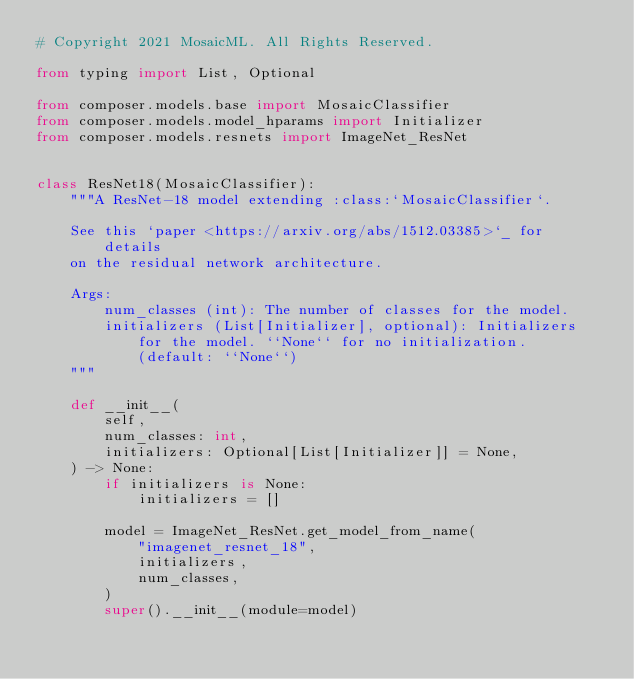<code> <loc_0><loc_0><loc_500><loc_500><_Python_># Copyright 2021 MosaicML. All Rights Reserved.

from typing import List, Optional

from composer.models.base import MosaicClassifier
from composer.models.model_hparams import Initializer
from composer.models.resnets import ImageNet_ResNet


class ResNet18(MosaicClassifier):
    """A ResNet-18 model extending :class:`MosaicClassifier`.

    See this `paper <https://arxiv.org/abs/1512.03385>`_ for details
    on the residual network architecture.

    Args:
        num_classes (int): The number of classes for the model.
        initializers (List[Initializer], optional): Initializers
            for the model. ``None`` for no initialization.
            (default: ``None``)
    """

    def __init__(
        self,
        num_classes: int,
        initializers: Optional[List[Initializer]] = None,
    ) -> None:
        if initializers is None:
            initializers = []

        model = ImageNet_ResNet.get_model_from_name(
            "imagenet_resnet_18",
            initializers,
            num_classes,
        )
        super().__init__(module=model)
</code> 